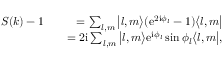Convert formula to latex. <formula><loc_0><loc_0><loc_500><loc_500>\begin{array} { r l r } { S ( k ) - 1 } & { = \sum _ { l , m } \left | l , m \right \rangle ( e ^ { 2 i \phi _ { l } } - 1 ) \left \langle l , m \right | } \\ & { = 2 i \sum _ { l , m } \left | l , m \right \rangle e ^ { i \phi _ { l } } \sin \phi _ { l } \left \langle l , m \right | , } \end{array}</formula> 